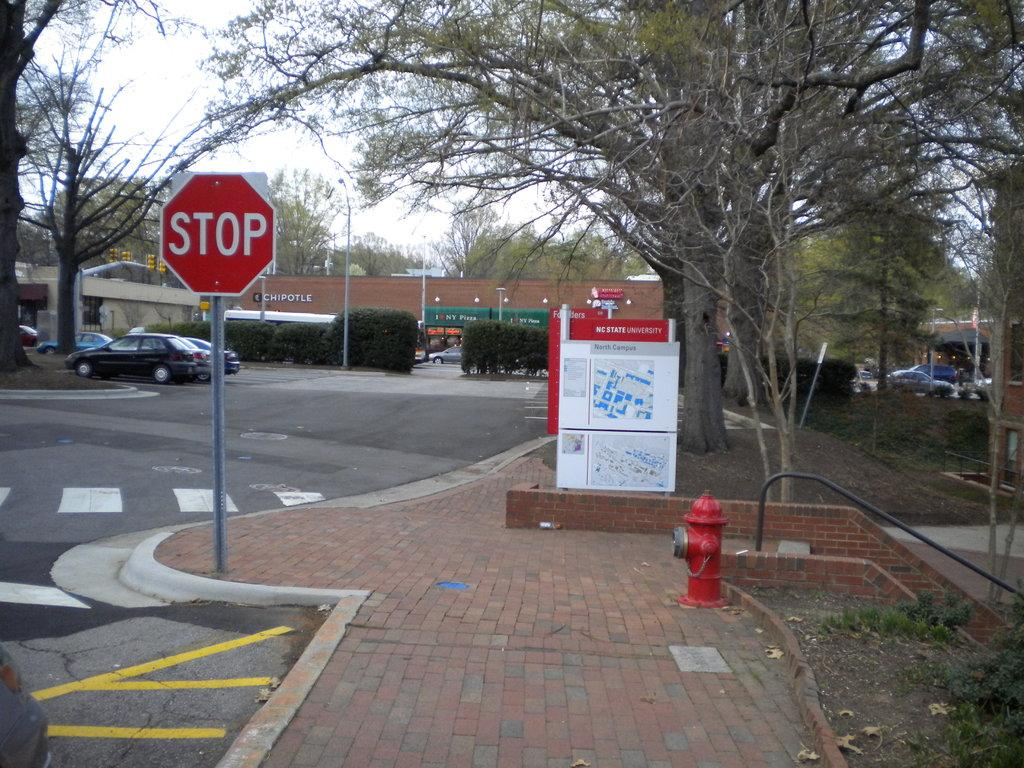<image>
Create a compact narrative representing the image presented. A stop sign next to a brick sidewalk in front of a NC State University North Campus map. 